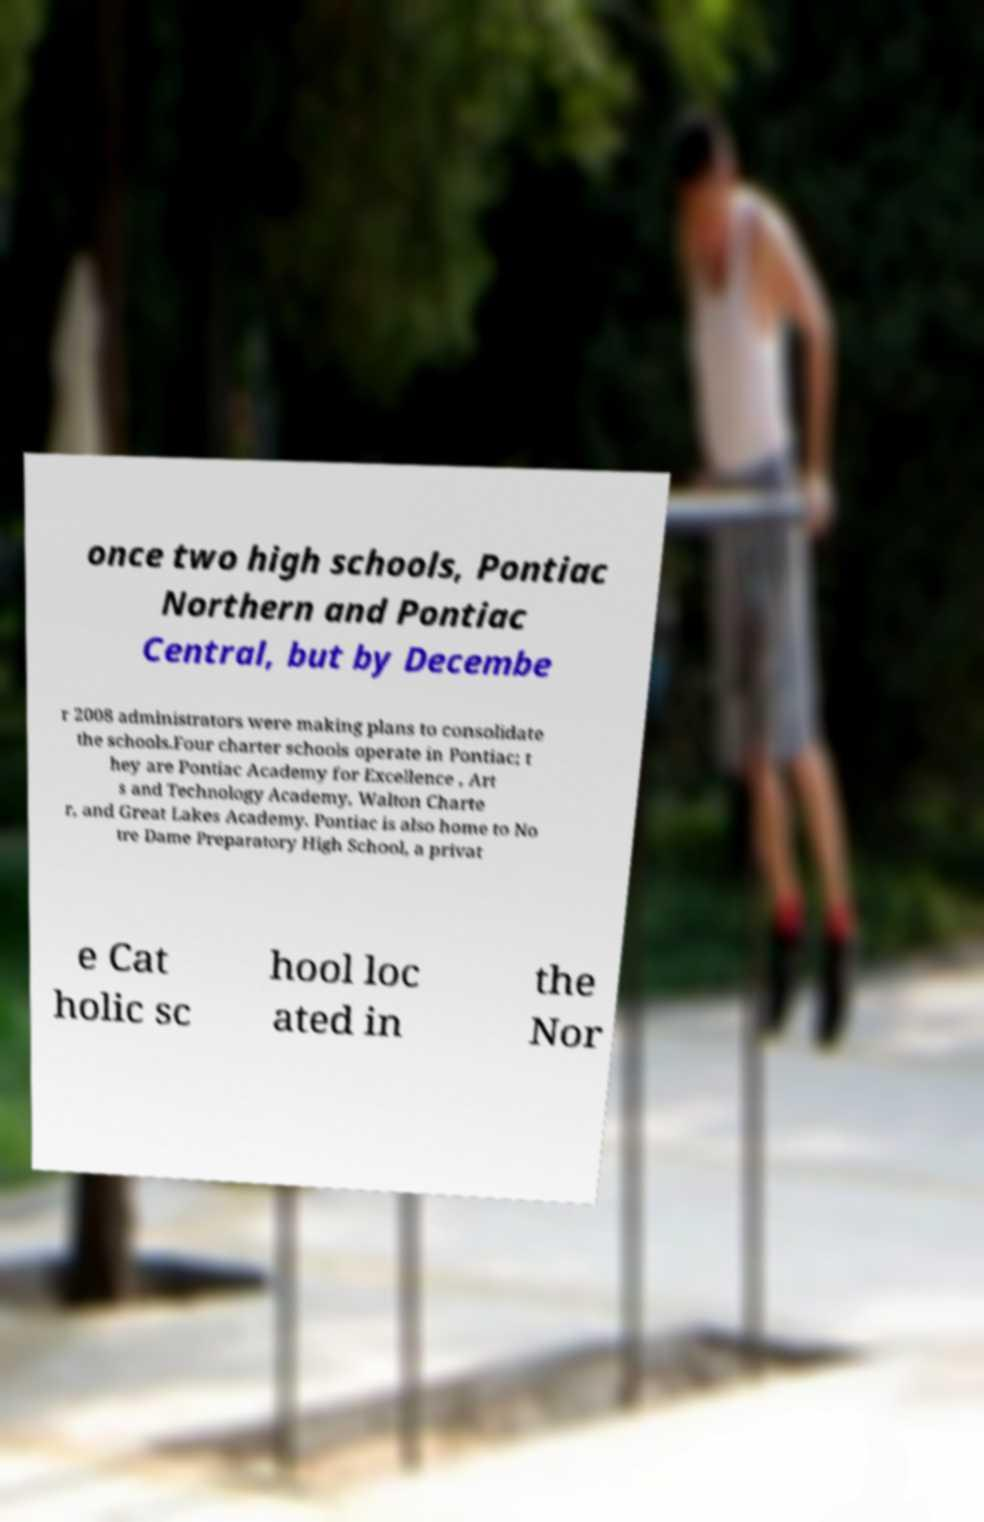Could you assist in decoding the text presented in this image and type it out clearly? once two high schools, Pontiac Northern and Pontiac Central, but by Decembe r 2008 administrators were making plans to consolidate the schools.Four charter schools operate in Pontiac; t hey are Pontiac Academy for Excellence , Art s and Technology Academy, Walton Charte r, and Great Lakes Academy. Pontiac is also home to No tre Dame Preparatory High School, a privat e Cat holic sc hool loc ated in the Nor 